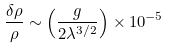Convert formula to latex. <formula><loc_0><loc_0><loc_500><loc_500>\frac { \delta \rho } { \rho } \sim \left ( \frac { g } { 2 \lambda ^ { 3 / 2 } } \right ) \times 1 0 ^ { - 5 }</formula> 